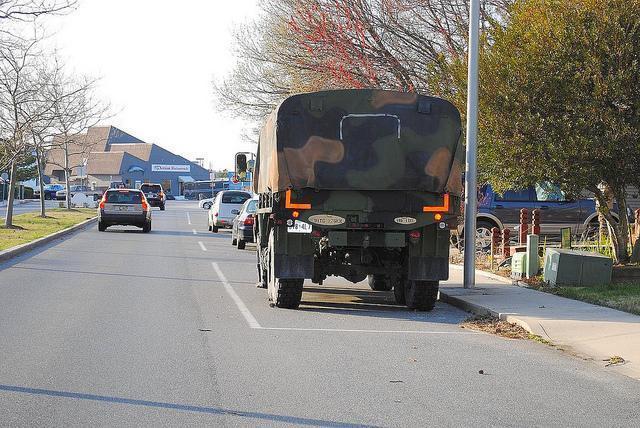How many trucks are visible?
Give a very brief answer. 2. 